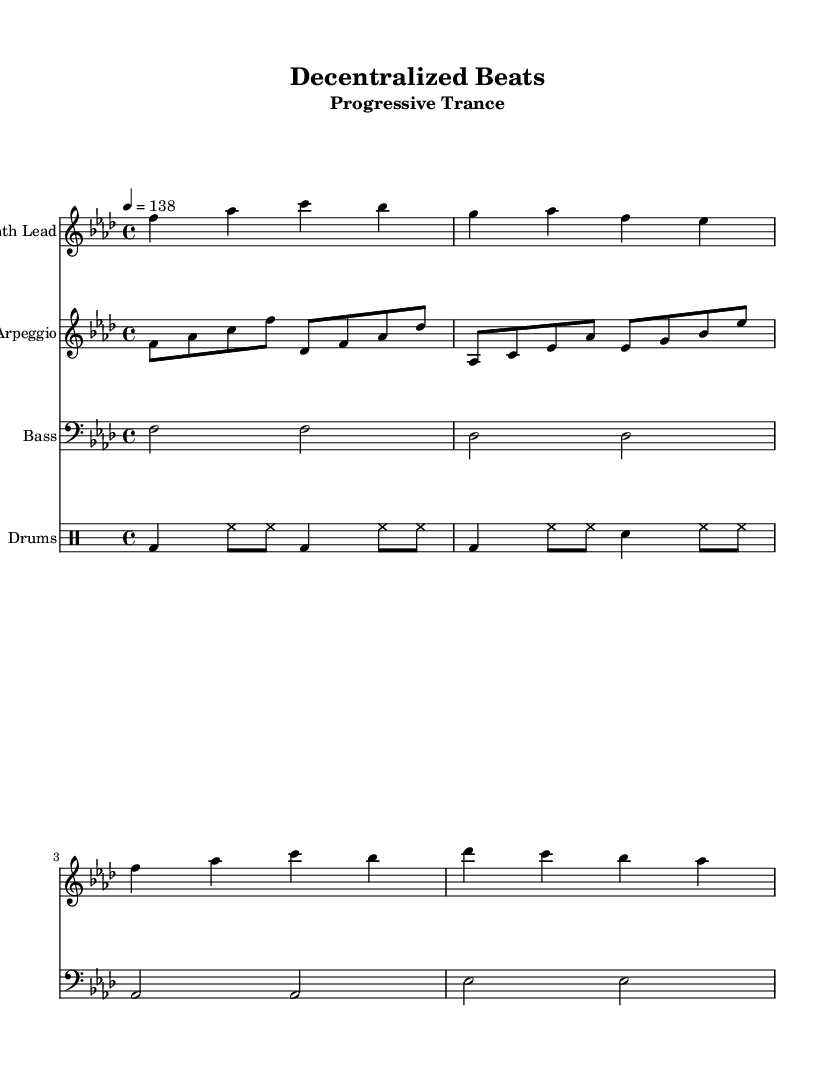What is the key signature of this music? The key signature is indicated by the number of flats or sharps at the beginning of the staff. In this piece, the key signature shows four flats, signifying it is in F minor.
Answer: F minor What is the time signature of this piece? The time signature is found right after the clef and key signature. This piece has a time signature of 4/4, which means there are four beats in each measure, and the quarter note gets one beat.
Answer: 4/4 What is the tempo indicated in the sheet music? The tempo is specified at the top of the score, declaring the beats per minute. Here, it states "4 = 138", indicating a moderate tempo of 138 beats per minute.
Answer: 138 How many measures are in the synth lead section? To find the number of measures, count the bar lines in the synth lead part. There are 4 measures present in this section, as there are four sets of notes separated by bar lines.
Answer: 4 What kind of rhythmic pattern is used in the drum section? The drum section contains various rhythmic elements, but it primarily uses a pattern incorporating kick drums, hi-hats, and snare, denoted by the use of bd, hh, and sn in the drummode. This suggests a typical dance rhythm that alternates between bass and high-hat sounds.
Answer: Kick, hi-hat, snare Which instrument plays the melody in this arrangement? The melody of this piece is primarily carried by the "Synth Lead" staff. This is indicated by the absence of a bass clef and the presence of the instrument name at the beginning of this staff.
Answer: Synth Lead What is the general feel of the music style based on the provided information? The music style is characterized by a repetitive structure, driving basslines, and atmospheric synthesizer melodies, elements that are typical of Progressive Trance, which often emphasizes build-ups and extended sections.
Answer: Progressive Trance 